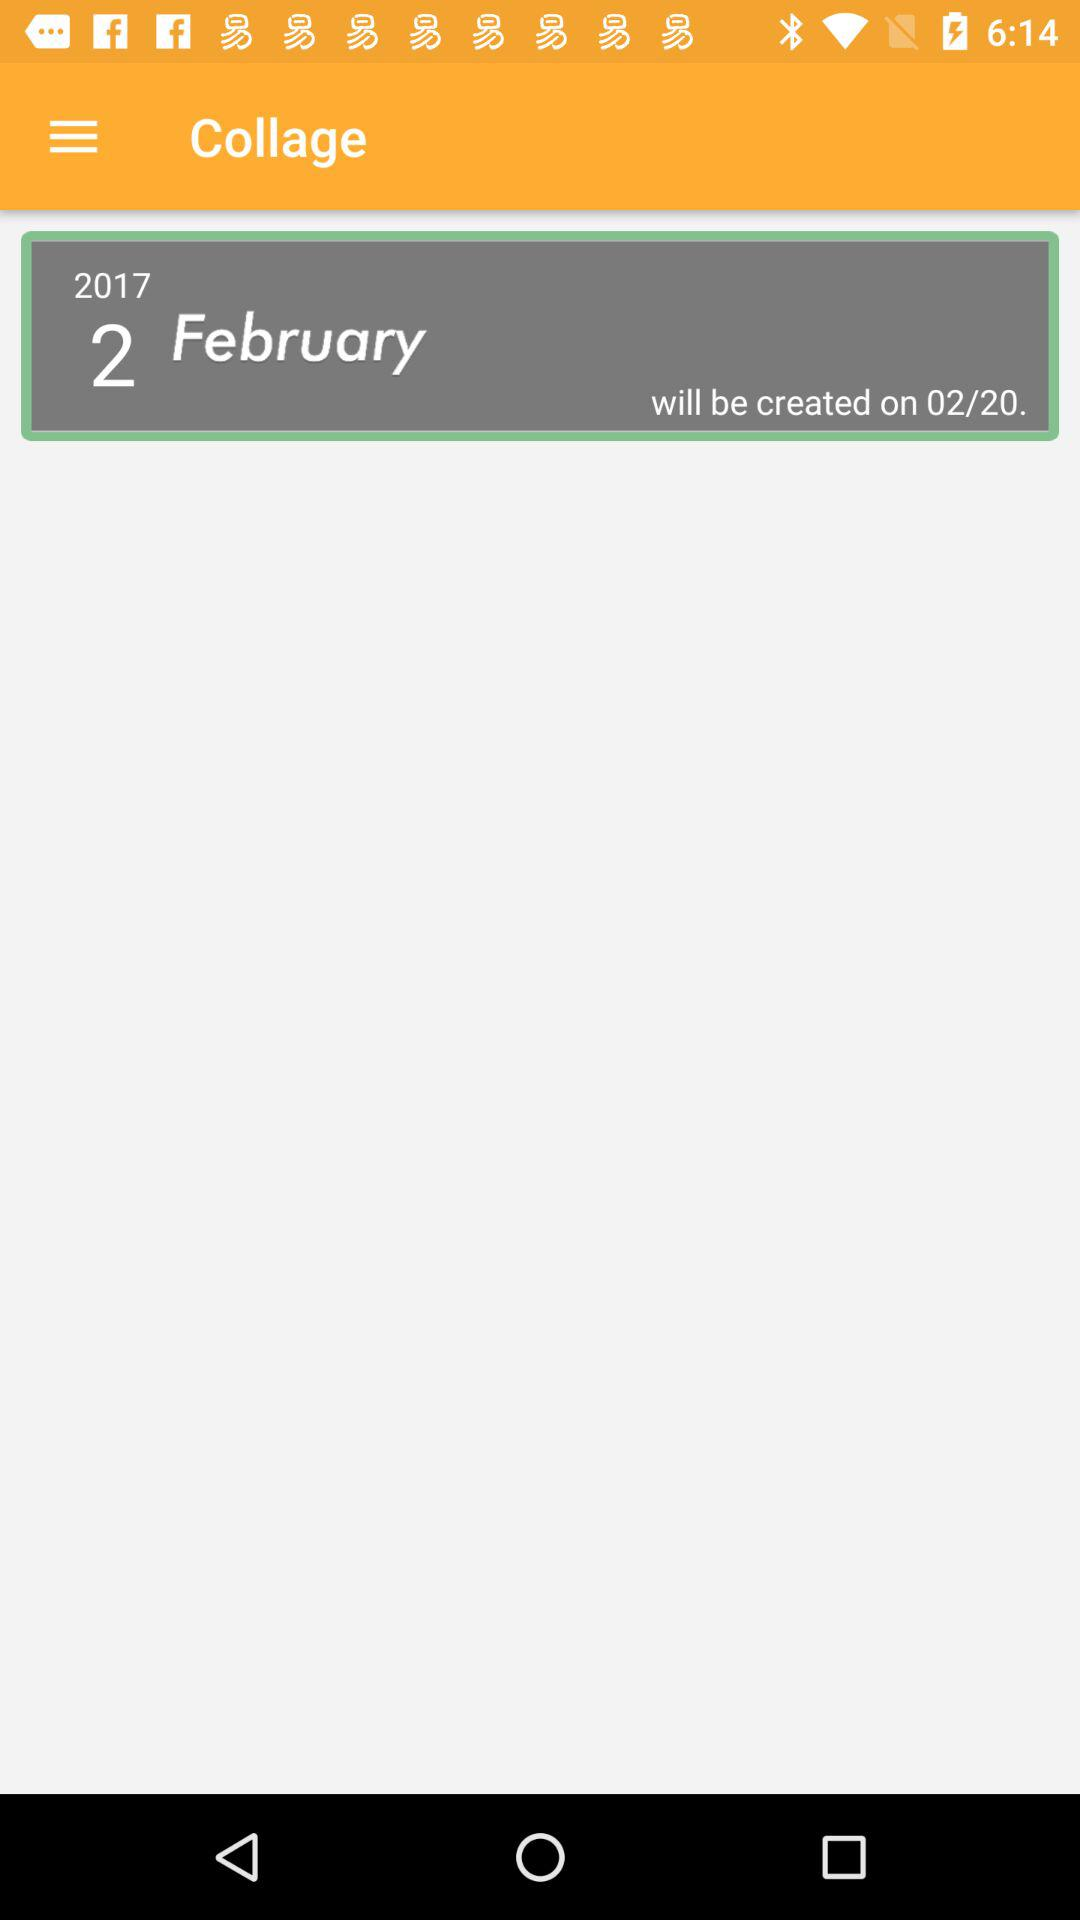What is the year of the collage?
Answer the question using a single word or phrase. 2017 